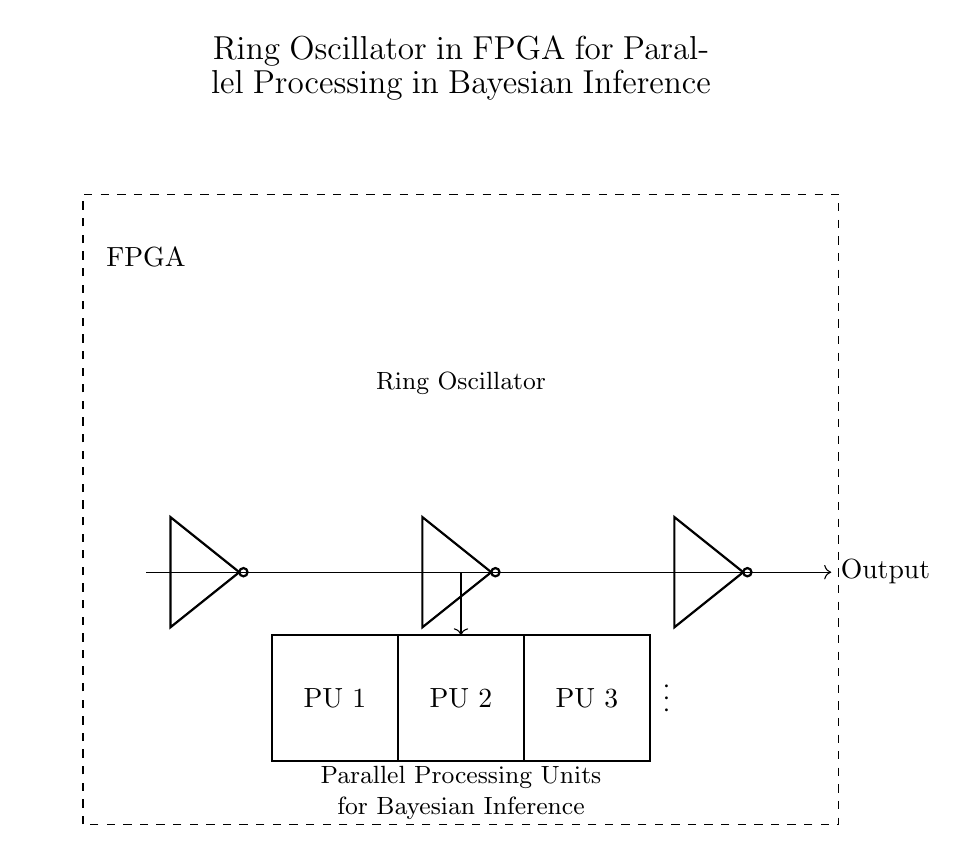What type of oscillator is depicted? The circuit diagram shows a ring oscillator, which is characterized by the arrangement of inverters (not gates) connected in a circular format. The output from the last inverter is fed back to the first inverter, creating a feedback loop that enables oscillation.
Answer: ring oscillator How many inverters are in this ring oscillator? The diagram illustrates three inverters connected in series, forming the essential elements of the ring oscillator. Each inverter contributes to the oscillation by introducing a phase shift, and in this case, the total is three.
Answer: three What is the purpose of the feedback connection? The feedback connection is critical as it allows the output of the last inverter to reconnect to the input of the first inverter, sustaining the oscillation by creating a continuous loop. This feedback maintains the timing and frequency of the output signal.
Answer: sustain oscillation What is the primary function of the parallel processing units? The parallel processing units are designated for executing Bayesian inference algorithms, enabling fast computation by leveraging concurrent processing of multiple data inputs in the FPGA. Therefore, their main function is to enhance computational efficiency.
Answer: execute Bayesian inference algorithms What does the output indicate in this oscillator design? The output of the ring oscillator provides a clock signal that can be used to synchronize operations within the parallel processing units. This signal is essential for managing timing for the algorithms that rely on precise execution sequences.
Answer: clock signal Which component connects the ring oscillator to the processing units? The diagram shows an arrow leading from the output of the last inverter to the parallel processing units, indicating that the inverter's output serves as the connecting component that delivers the signal for processing.
Answer: last inverter output 